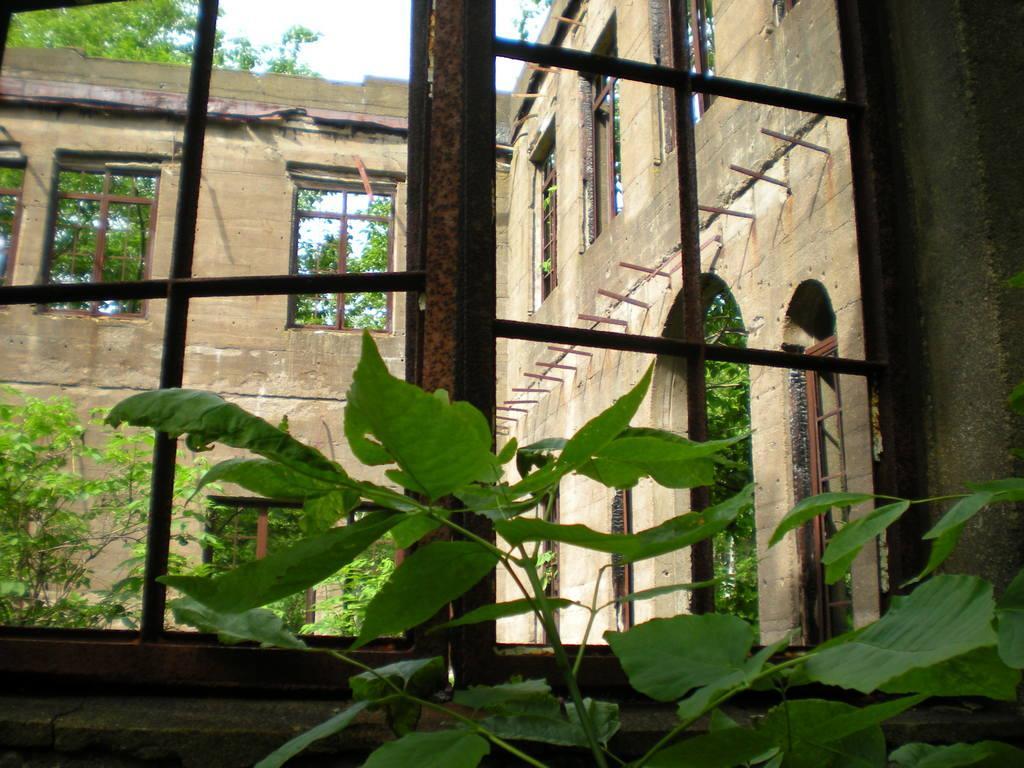Could you give a brief overview of what you see in this image? There are plants, windows, walls and trees. 